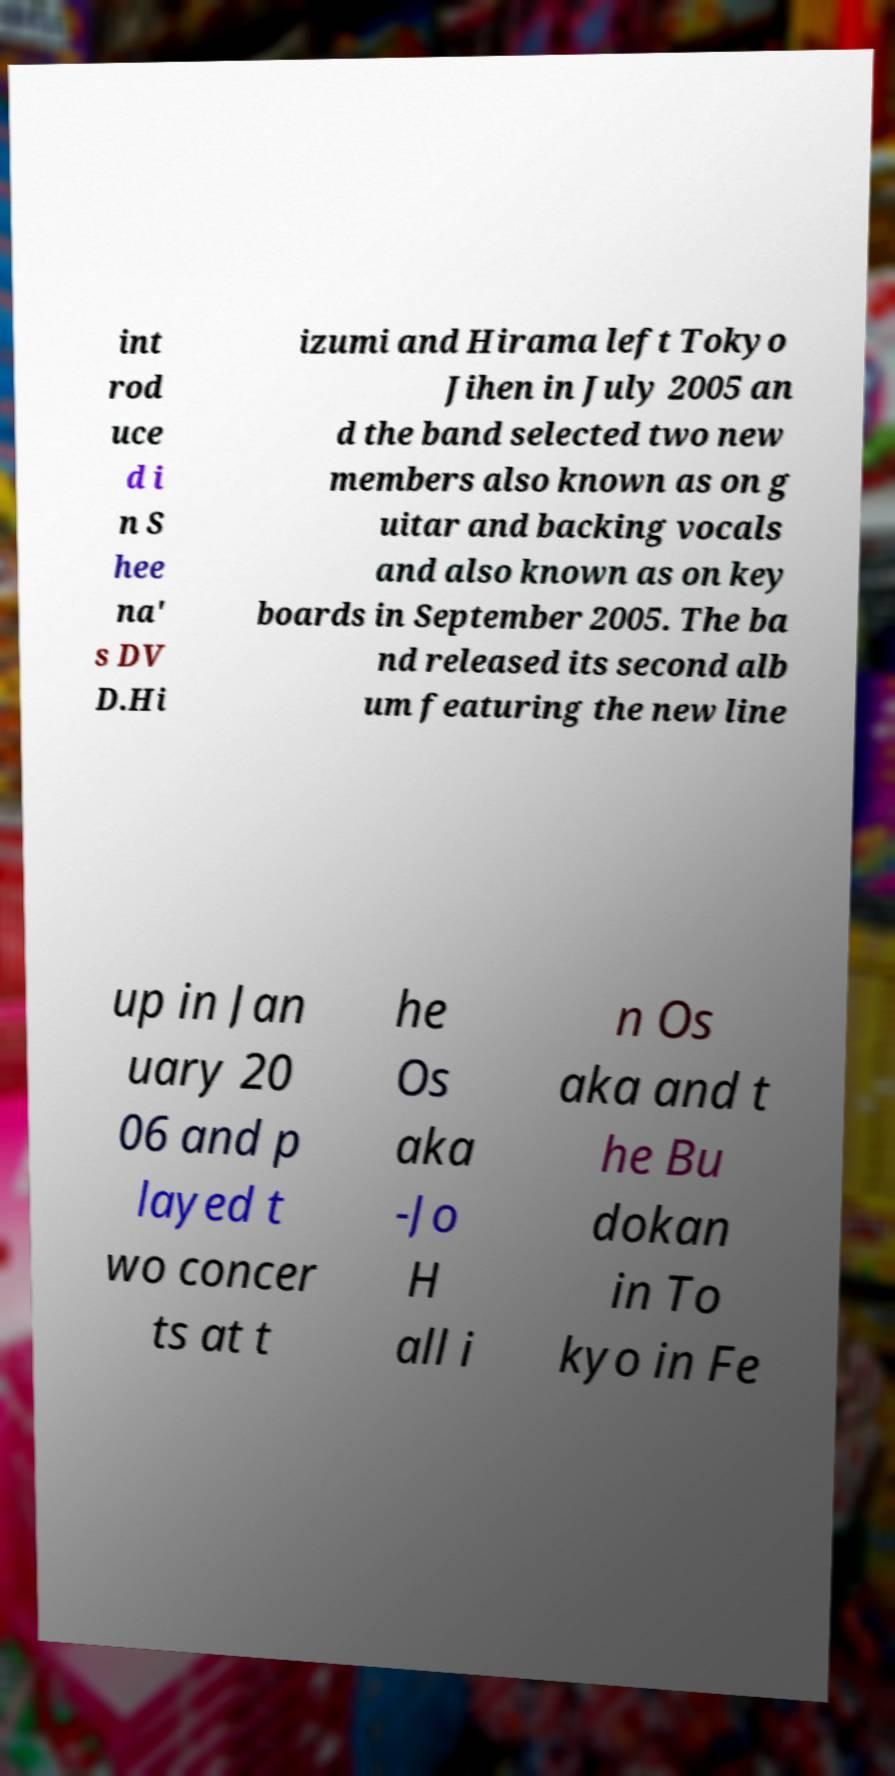There's text embedded in this image that I need extracted. Can you transcribe it verbatim? int rod uce d i n S hee na' s DV D.Hi izumi and Hirama left Tokyo Jihen in July 2005 an d the band selected two new members also known as on g uitar and backing vocals and also known as on key boards in September 2005. The ba nd released its second alb um featuring the new line up in Jan uary 20 06 and p layed t wo concer ts at t he Os aka -Jo H all i n Os aka and t he Bu dokan in To kyo in Fe 